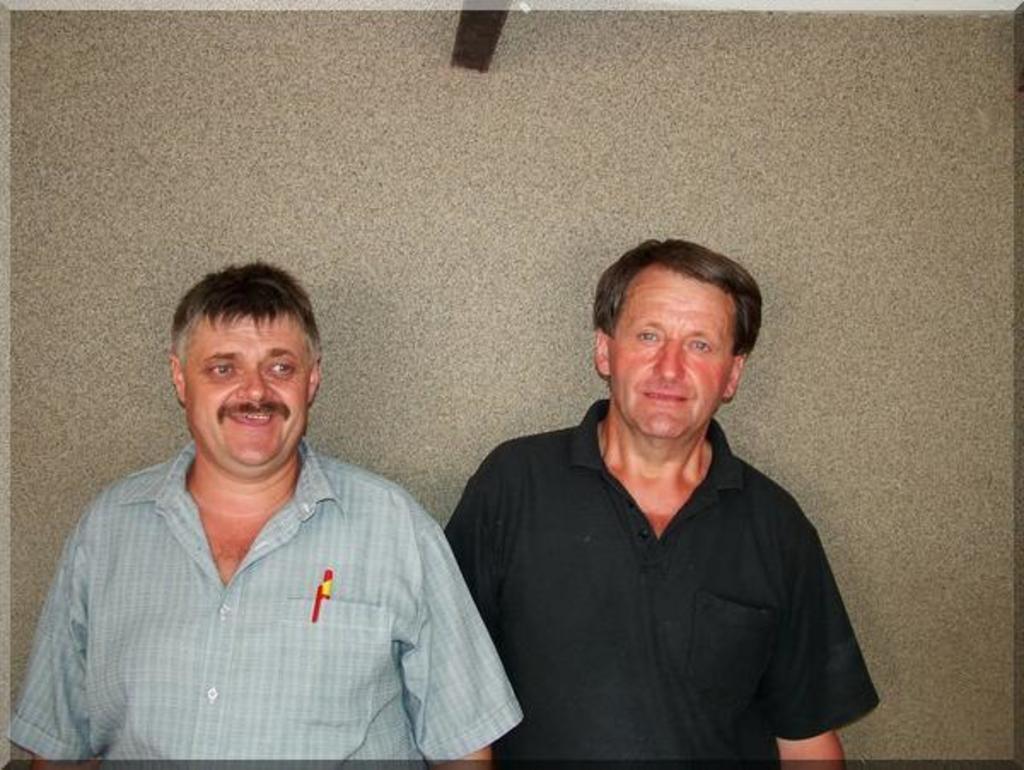Can you describe this image briefly? In this picture we can see two men, they both are smiling, and the right side man wore a black color T-shirt. 